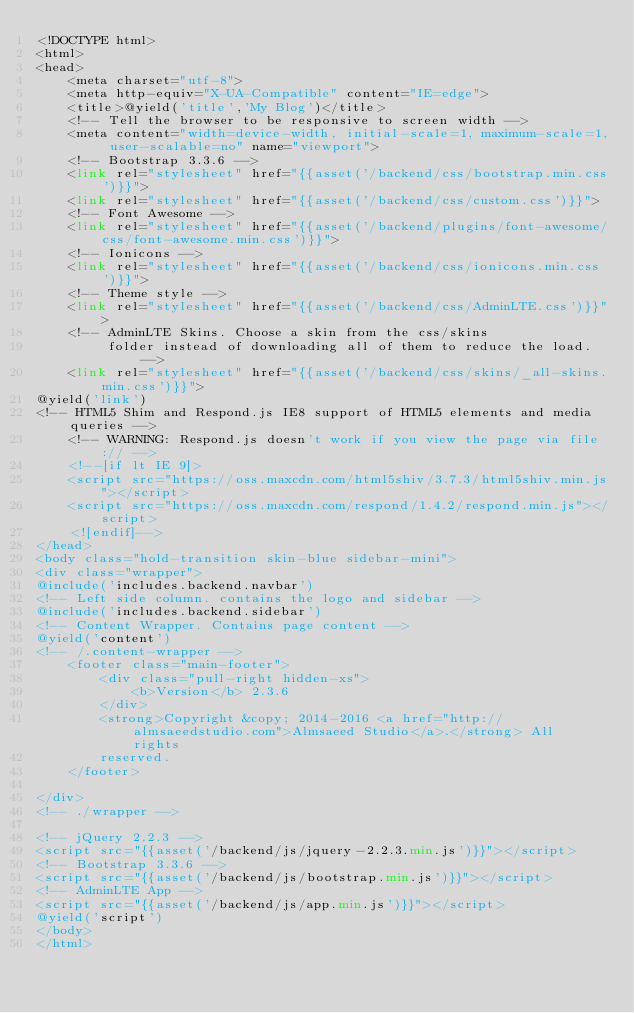Convert code to text. <code><loc_0><loc_0><loc_500><loc_500><_PHP_><!DOCTYPE html>
<html>
<head>
    <meta charset="utf-8">
    <meta http-equiv="X-UA-Compatible" content="IE=edge">
    <title>@yield('title','My Blog')</title>
    <!-- Tell the browser to be responsive to screen width -->
    <meta content="width=device-width, initial-scale=1, maximum-scale=1, user-scalable=no" name="viewport">
    <!-- Bootstrap 3.3.6 -->
    <link rel="stylesheet" href="{{asset('/backend/css/bootstrap.min.css')}}">
    <link rel="stylesheet" href="{{asset('/backend/css/custom.css')}}">
    <!-- Font Awesome -->
    <link rel="stylesheet" href="{{asset('/backend/plugins/font-awesome/css/font-awesome.min.css')}}">
    <!-- Ionicons -->
    <link rel="stylesheet" href="{{asset('/backend/css/ionicons.min.css')}}">
    <!-- Theme style -->
    <link rel="stylesheet" href="{{asset('/backend/css/AdminLTE.css')}}">
    <!-- AdminLTE Skins. Choose a skin from the css/skins
         folder instead of downloading all of them to reduce the load. -->
    <link rel="stylesheet" href="{{asset('/backend/css/skins/_all-skins.min.css')}}">
@yield('link')
<!-- HTML5 Shim and Respond.js IE8 support of HTML5 elements and media queries -->
    <!-- WARNING: Respond.js doesn't work if you view the page via file:// -->
    <!--[if lt IE 9]>
    <script src="https://oss.maxcdn.com/html5shiv/3.7.3/html5shiv.min.js"></script>
    <script src="https://oss.maxcdn.com/respond/1.4.2/respond.min.js"></script>
    <![endif]-->
</head>
<body class="hold-transition skin-blue sidebar-mini">
<div class="wrapper">
@include('includes.backend.navbar')
<!-- Left side column. contains the logo and sidebar -->
@include('includes.backend.sidebar')
<!-- Content Wrapper. Contains page content -->
@yield('content')
<!-- /.content-wrapper -->
    <footer class="main-footer">
        <div class="pull-right hidden-xs">
            <b>Version</b> 2.3.6
        </div>
        <strong>Copyright &copy; 2014-2016 <a href="http://almsaeedstudio.com">Almsaeed Studio</a>.</strong> All rights
        reserved.
    </footer>

</div>
<!-- ./wrapper -->

<!-- jQuery 2.2.3 -->
<script src="{{asset('/backend/js/jquery-2.2.3.min.js')}}"></script>
<!-- Bootstrap 3.3.6 -->
<script src="{{asset('/backend/js/bootstrap.min.js')}}"></script>
<!-- AdminLTE App -->
<script src="{{asset('/backend/js/app.min.js')}}"></script>
@yield('script')
</body>
</html>
</code> 